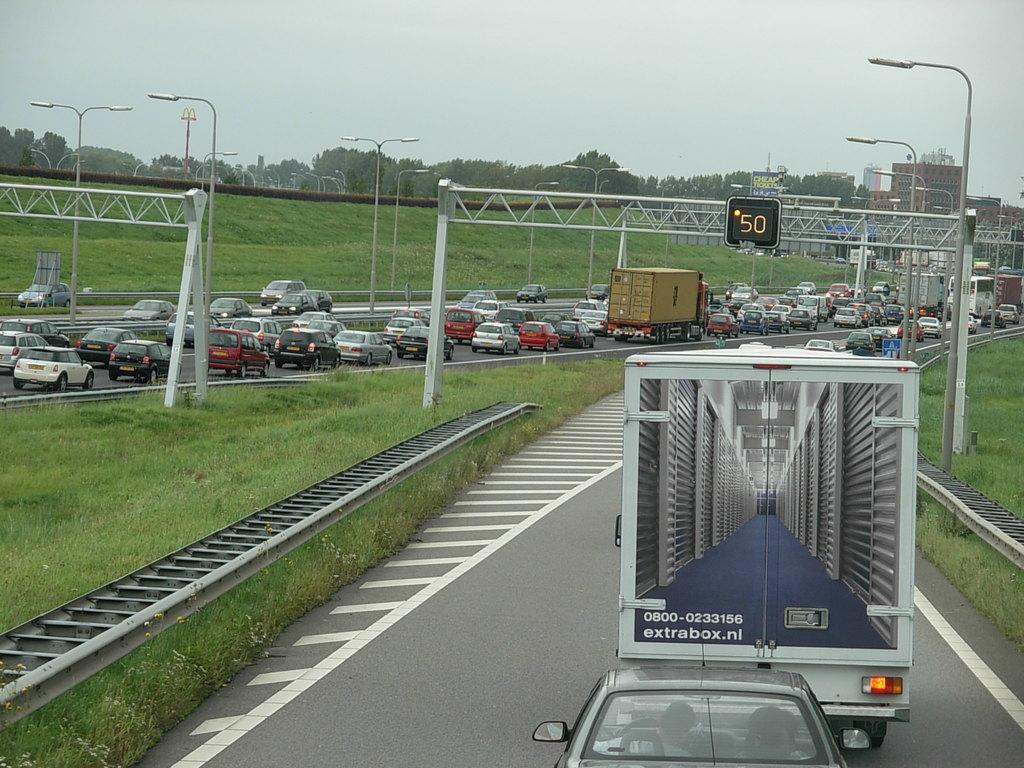Can you describe this image briefly? In this picture we can see few vehicles on the road, in the background we can find few poles, metal rods, digital screen, trees and buildings, also we can see grass. 